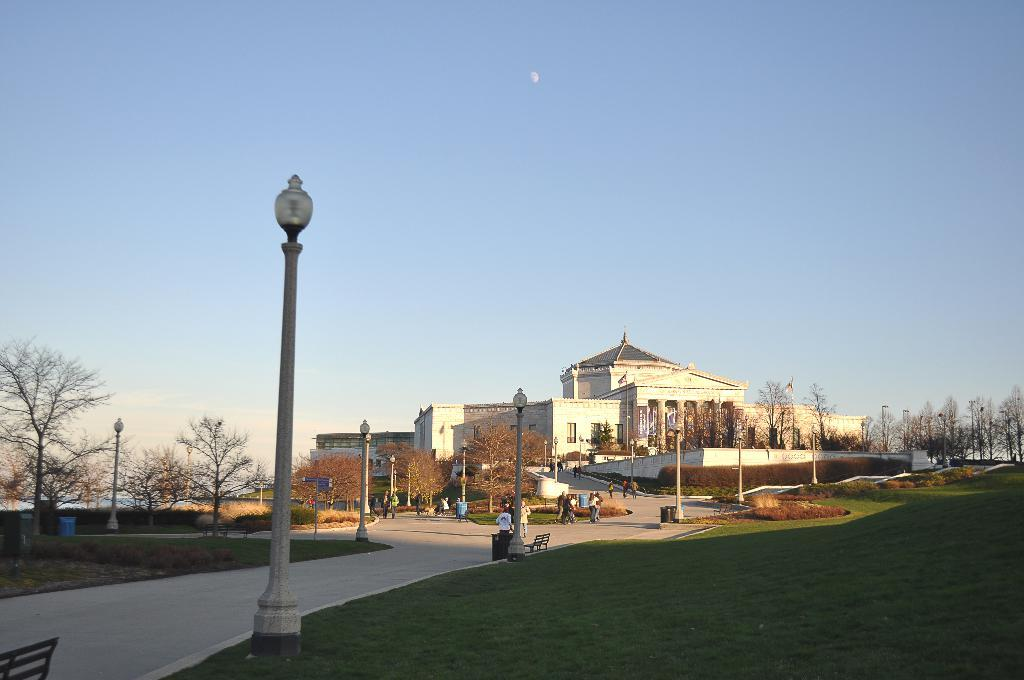What type of structures can be seen in the image? There are buildings in the image. What other objects are present in the image? There are poles and benches in the image. Are there any living beings in the image? Yes, there are people in the image. What can be seen in the background of the image? There are trees and sky visible in the background of the image. What is the ground made of in the image? The ground is made of grass at the bottom of the image. Can you describe the kiss between the beast and the person in the image? There is no kiss or beast present in the image. How does the twist in the pole affect the people sitting on the benches? There is no twist in the pole in the image, and the benches are not affected by any twists. 